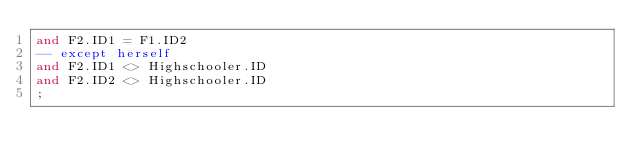<code> <loc_0><loc_0><loc_500><loc_500><_SQL_>and F2.ID1 = F1.ID2
-- except herself
and F2.ID1 <> Highschooler.ID
and F2.ID2 <> Highschooler.ID
;
</code> 